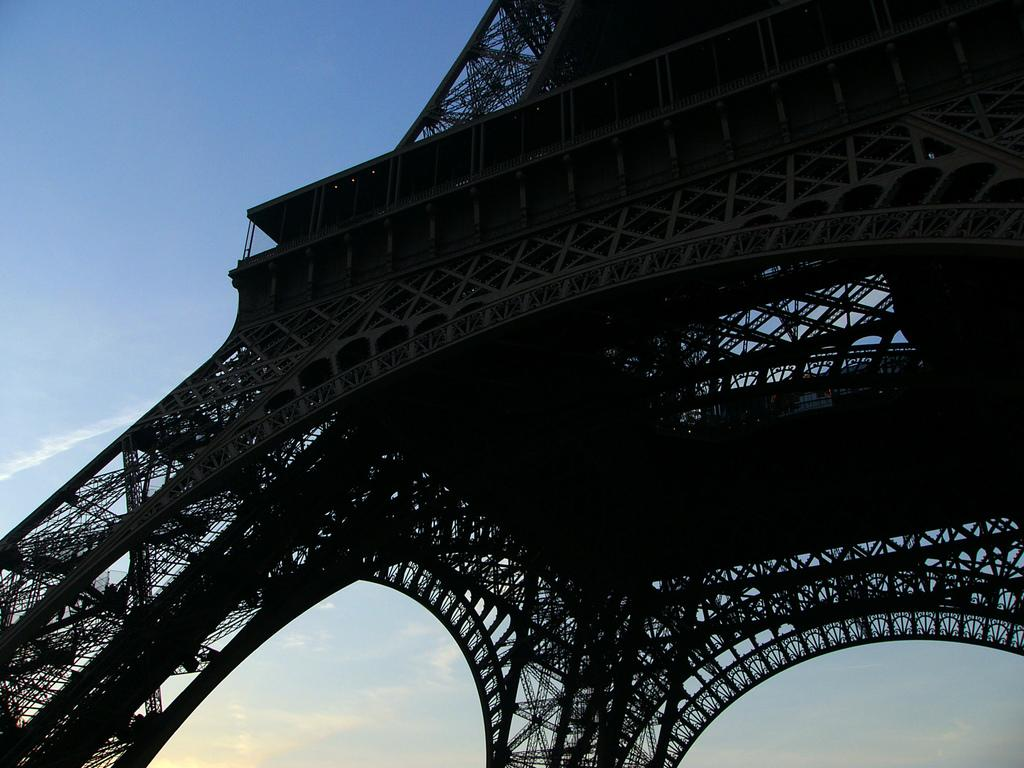What is the main structure in the image? There is a tower in the image. What can be seen in the background of the image? The sky is visible in the background of the image. What type of drink is being served by the judge in the image? There is no judge or drink present in the image; it only features a tower and the sky. 